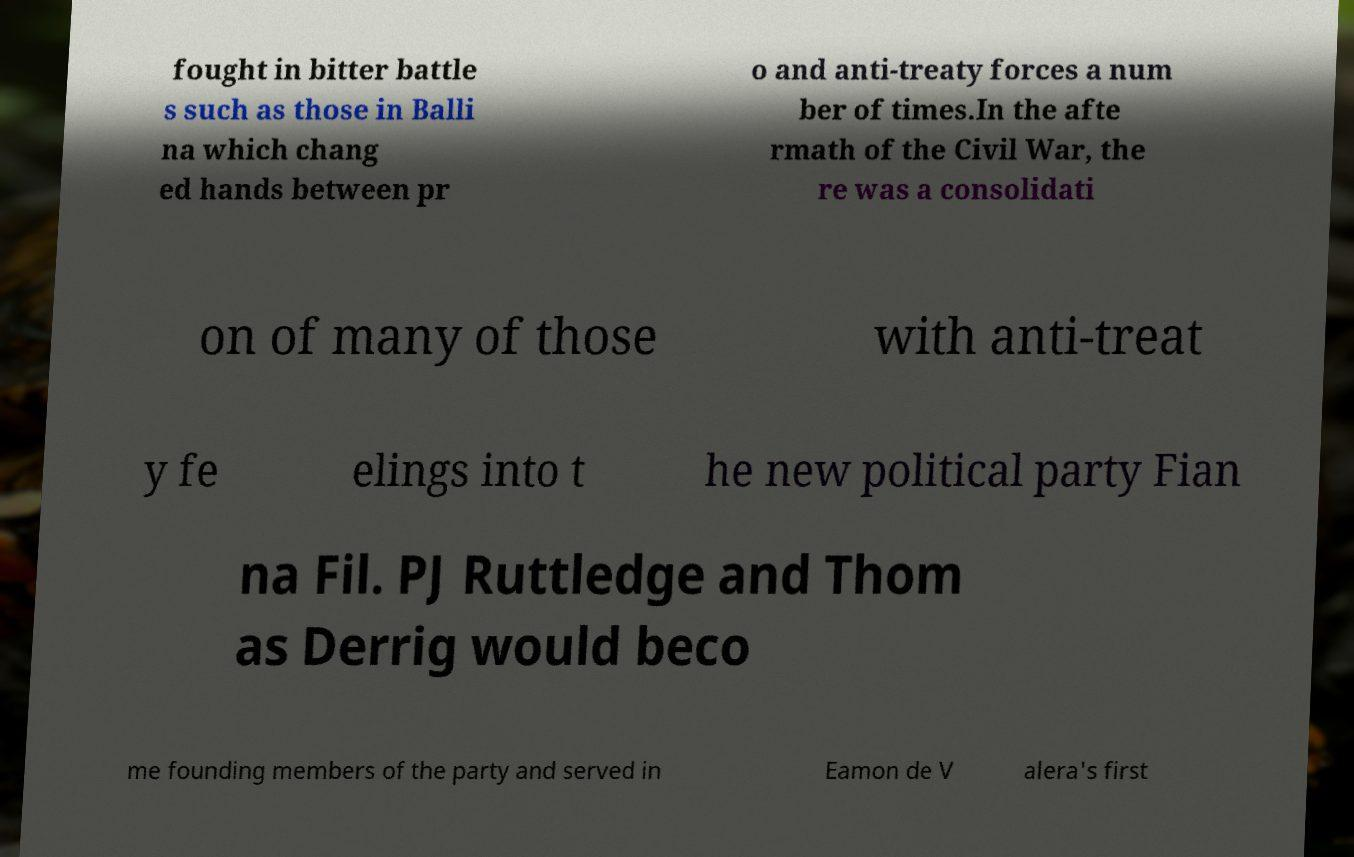Please identify and transcribe the text found in this image. fought in bitter battle s such as those in Balli na which chang ed hands between pr o and anti-treaty forces a num ber of times.In the afte rmath of the Civil War, the re was a consolidati on of many of those with anti-treat y fe elings into t he new political party Fian na Fil. PJ Ruttledge and Thom as Derrig would beco me founding members of the party and served in Eamon de V alera's first 